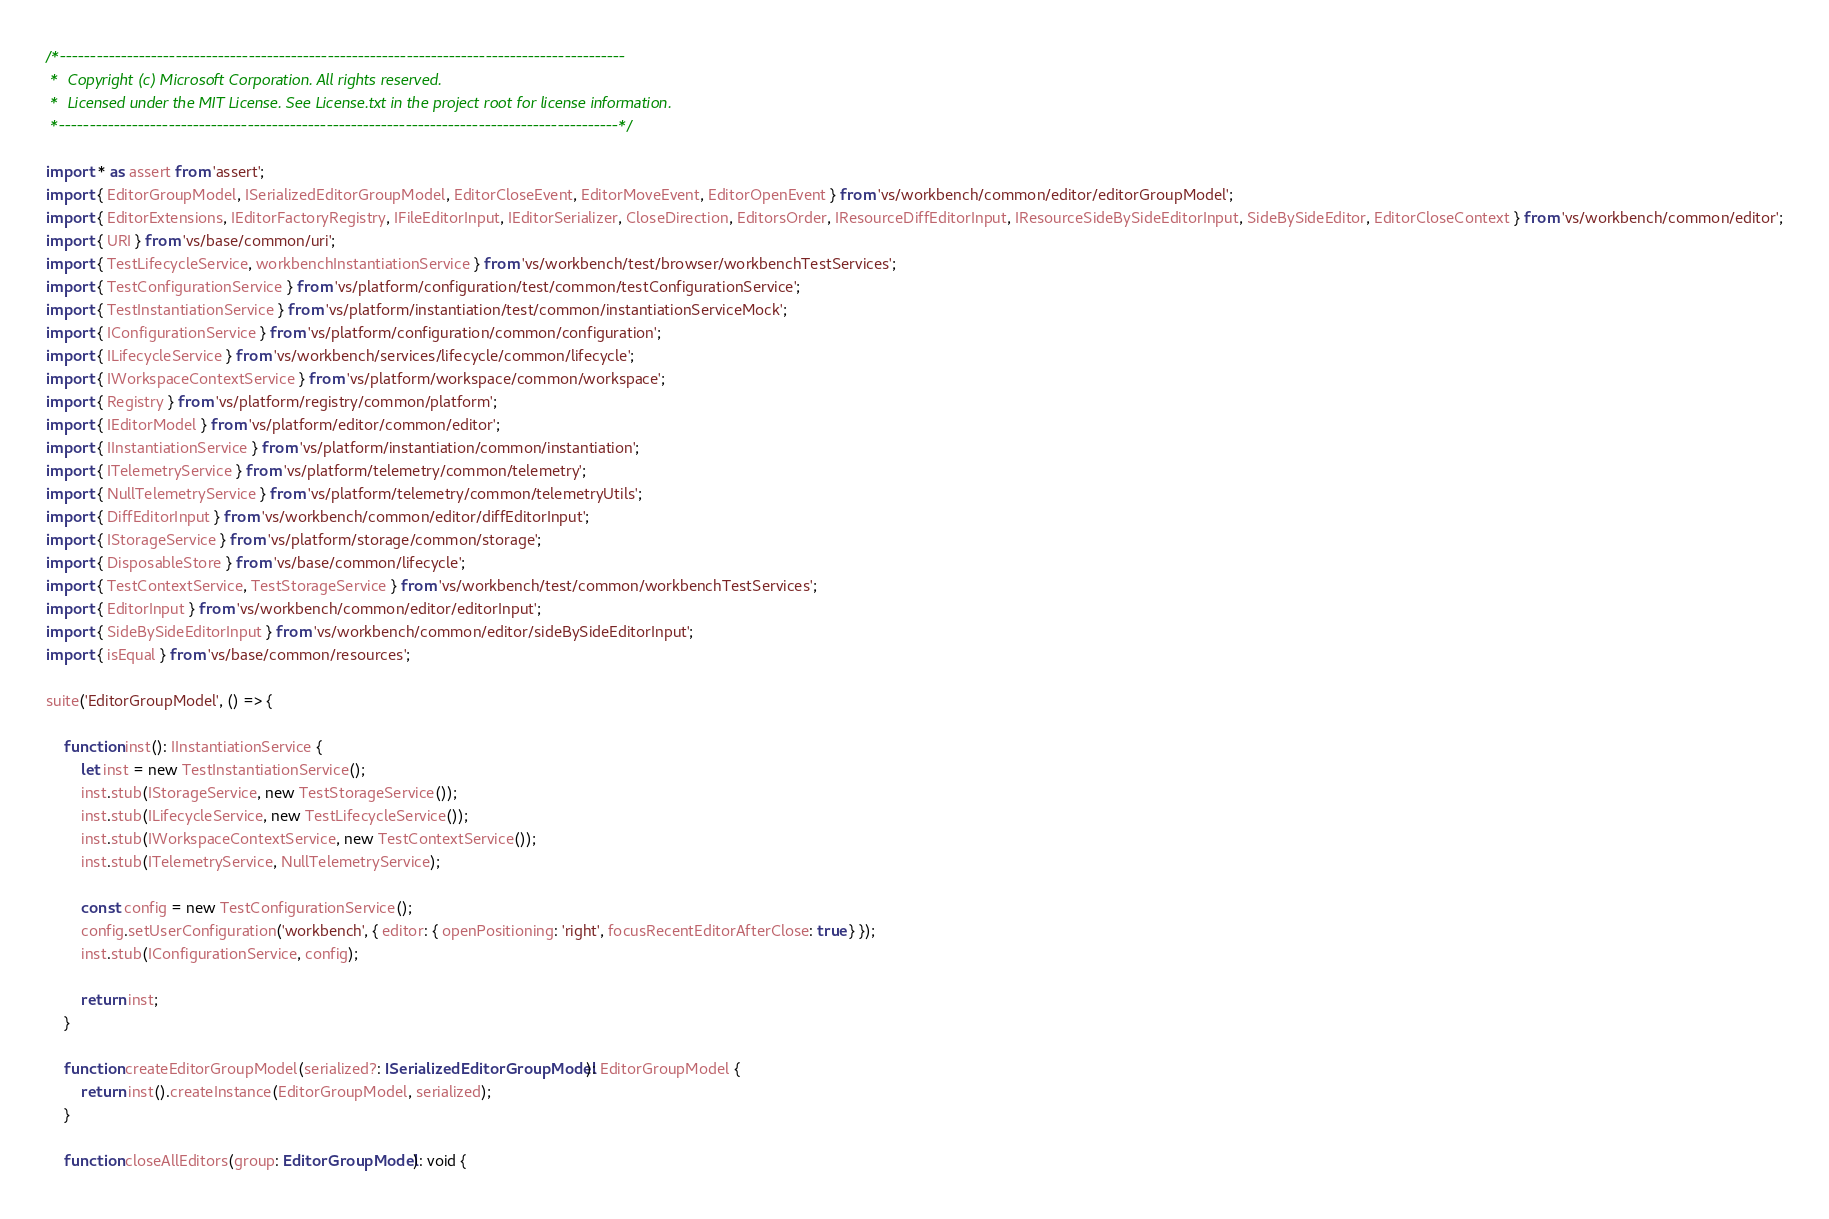Convert code to text. <code><loc_0><loc_0><loc_500><loc_500><_TypeScript_>/*---------------------------------------------------------------------------------------------
 *  Copyright (c) Microsoft Corporation. All rights reserved.
 *  Licensed under the MIT License. See License.txt in the project root for license information.
 *--------------------------------------------------------------------------------------------*/

import * as assert from 'assert';
import { EditorGroupModel, ISerializedEditorGroupModel, EditorCloseEvent, EditorMoveEvent, EditorOpenEvent } from 'vs/workbench/common/editor/editorGroupModel';
import { EditorExtensions, IEditorFactoryRegistry, IFileEditorInput, IEditorSerializer, CloseDirection, EditorsOrder, IResourceDiffEditorInput, IResourceSideBySideEditorInput, SideBySideEditor, EditorCloseContext } from 'vs/workbench/common/editor';
import { URI } from 'vs/base/common/uri';
import { TestLifecycleService, workbenchInstantiationService } from 'vs/workbench/test/browser/workbenchTestServices';
import { TestConfigurationService } from 'vs/platform/configuration/test/common/testConfigurationService';
import { TestInstantiationService } from 'vs/platform/instantiation/test/common/instantiationServiceMock';
import { IConfigurationService } from 'vs/platform/configuration/common/configuration';
import { ILifecycleService } from 'vs/workbench/services/lifecycle/common/lifecycle';
import { IWorkspaceContextService } from 'vs/platform/workspace/common/workspace';
import { Registry } from 'vs/platform/registry/common/platform';
import { IEditorModel } from 'vs/platform/editor/common/editor';
import { IInstantiationService } from 'vs/platform/instantiation/common/instantiation';
import { ITelemetryService } from 'vs/platform/telemetry/common/telemetry';
import { NullTelemetryService } from 'vs/platform/telemetry/common/telemetryUtils';
import { DiffEditorInput } from 'vs/workbench/common/editor/diffEditorInput';
import { IStorageService } from 'vs/platform/storage/common/storage';
import { DisposableStore } from 'vs/base/common/lifecycle';
import { TestContextService, TestStorageService } from 'vs/workbench/test/common/workbenchTestServices';
import { EditorInput } from 'vs/workbench/common/editor/editorInput';
import { SideBySideEditorInput } from 'vs/workbench/common/editor/sideBySideEditorInput';
import { isEqual } from 'vs/base/common/resources';

suite('EditorGroupModel', () => {

	function inst(): IInstantiationService {
		let inst = new TestInstantiationService();
		inst.stub(IStorageService, new TestStorageService());
		inst.stub(ILifecycleService, new TestLifecycleService());
		inst.stub(IWorkspaceContextService, new TestContextService());
		inst.stub(ITelemetryService, NullTelemetryService);

		const config = new TestConfigurationService();
		config.setUserConfiguration('workbench', { editor: { openPositioning: 'right', focusRecentEditorAfterClose: true } });
		inst.stub(IConfigurationService, config);

		return inst;
	}

	function createEditorGroupModel(serialized?: ISerializedEditorGroupModel): EditorGroupModel {
		return inst().createInstance(EditorGroupModel, serialized);
	}

	function closeAllEditors(group: EditorGroupModel): void {</code> 